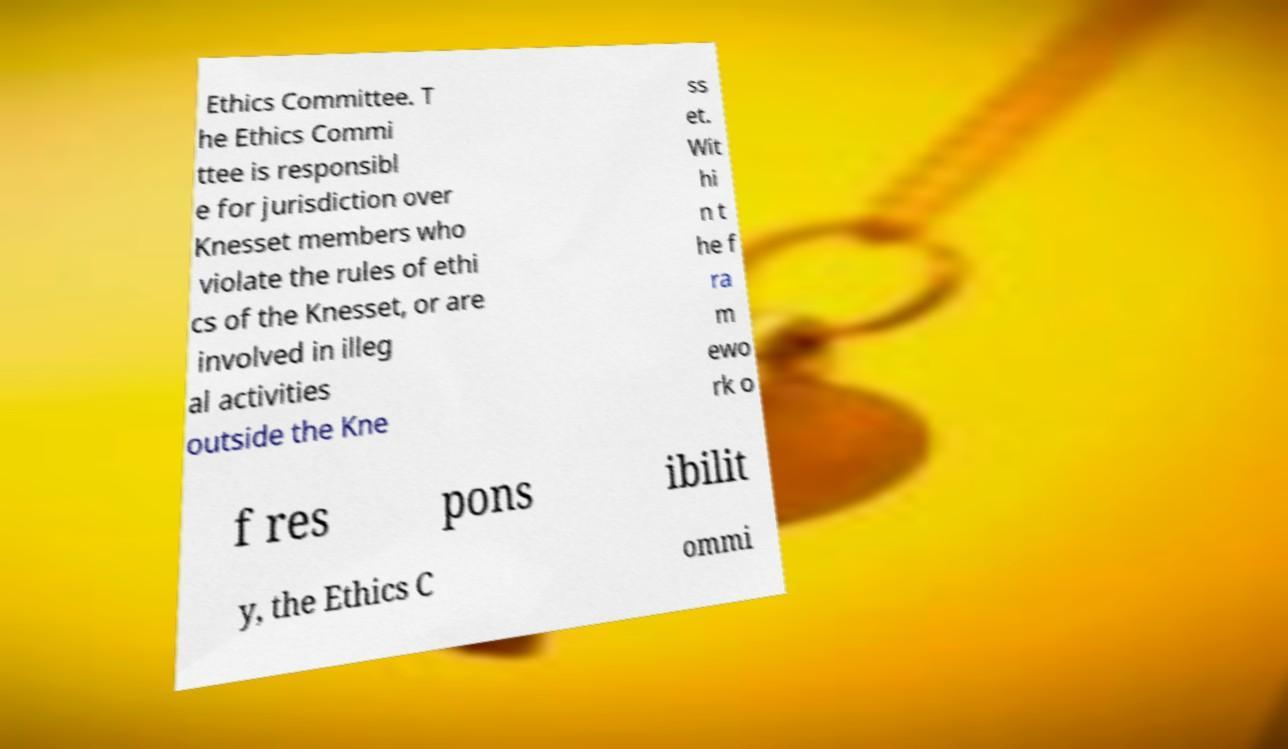Could you assist in decoding the text presented in this image and type it out clearly? Ethics Committee. T he Ethics Commi ttee is responsibl e for jurisdiction over Knesset members who violate the rules of ethi cs of the Knesset, or are involved in illeg al activities outside the Kne ss et. Wit hi n t he f ra m ewo rk o f res pons ibilit y, the Ethics C ommi 